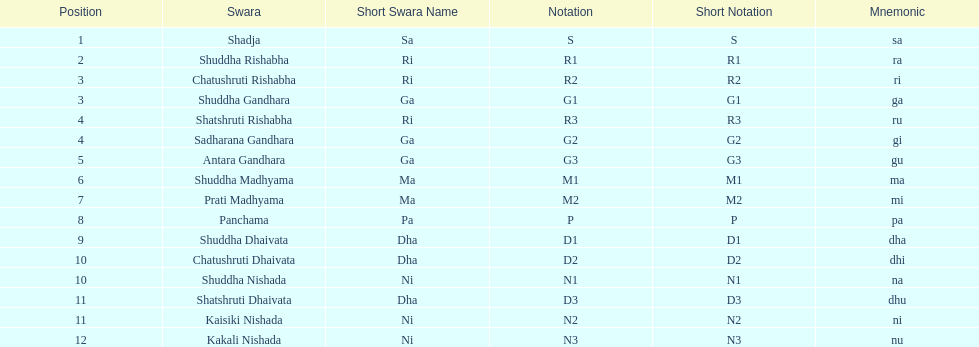Other than m1 how many notations have "1" in them? 4. 